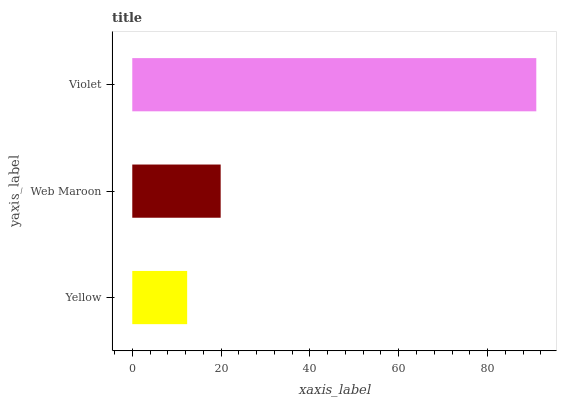Is Yellow the minimum?
Answer yes or no. Yes. Is Violet the maximum?
Answer yes or no. Yes. Is Web Maroon the minimum?
Answer yes or no. No. Is Web Maroon the maximum?
Answer yes or no. No. Is Web Maroon greater than Yellow?
Answer yes or no. Yes. Is Yellow less than Web Maroon?
Answer yes or no. Yes. Is Yellow greater than Web Maroon?
Answer yes or no. No. Is Web Maroon less than Yellow?
Answer yes or no. No. Is Web Maroon the high median?
Answer yes or no. Yes. Is Web Maroon the low median?
Answer yes or no. Yes. Is Violet the high median?
Answer yes or no. No. Is Violet the low median?
Answer yes or no. No. 